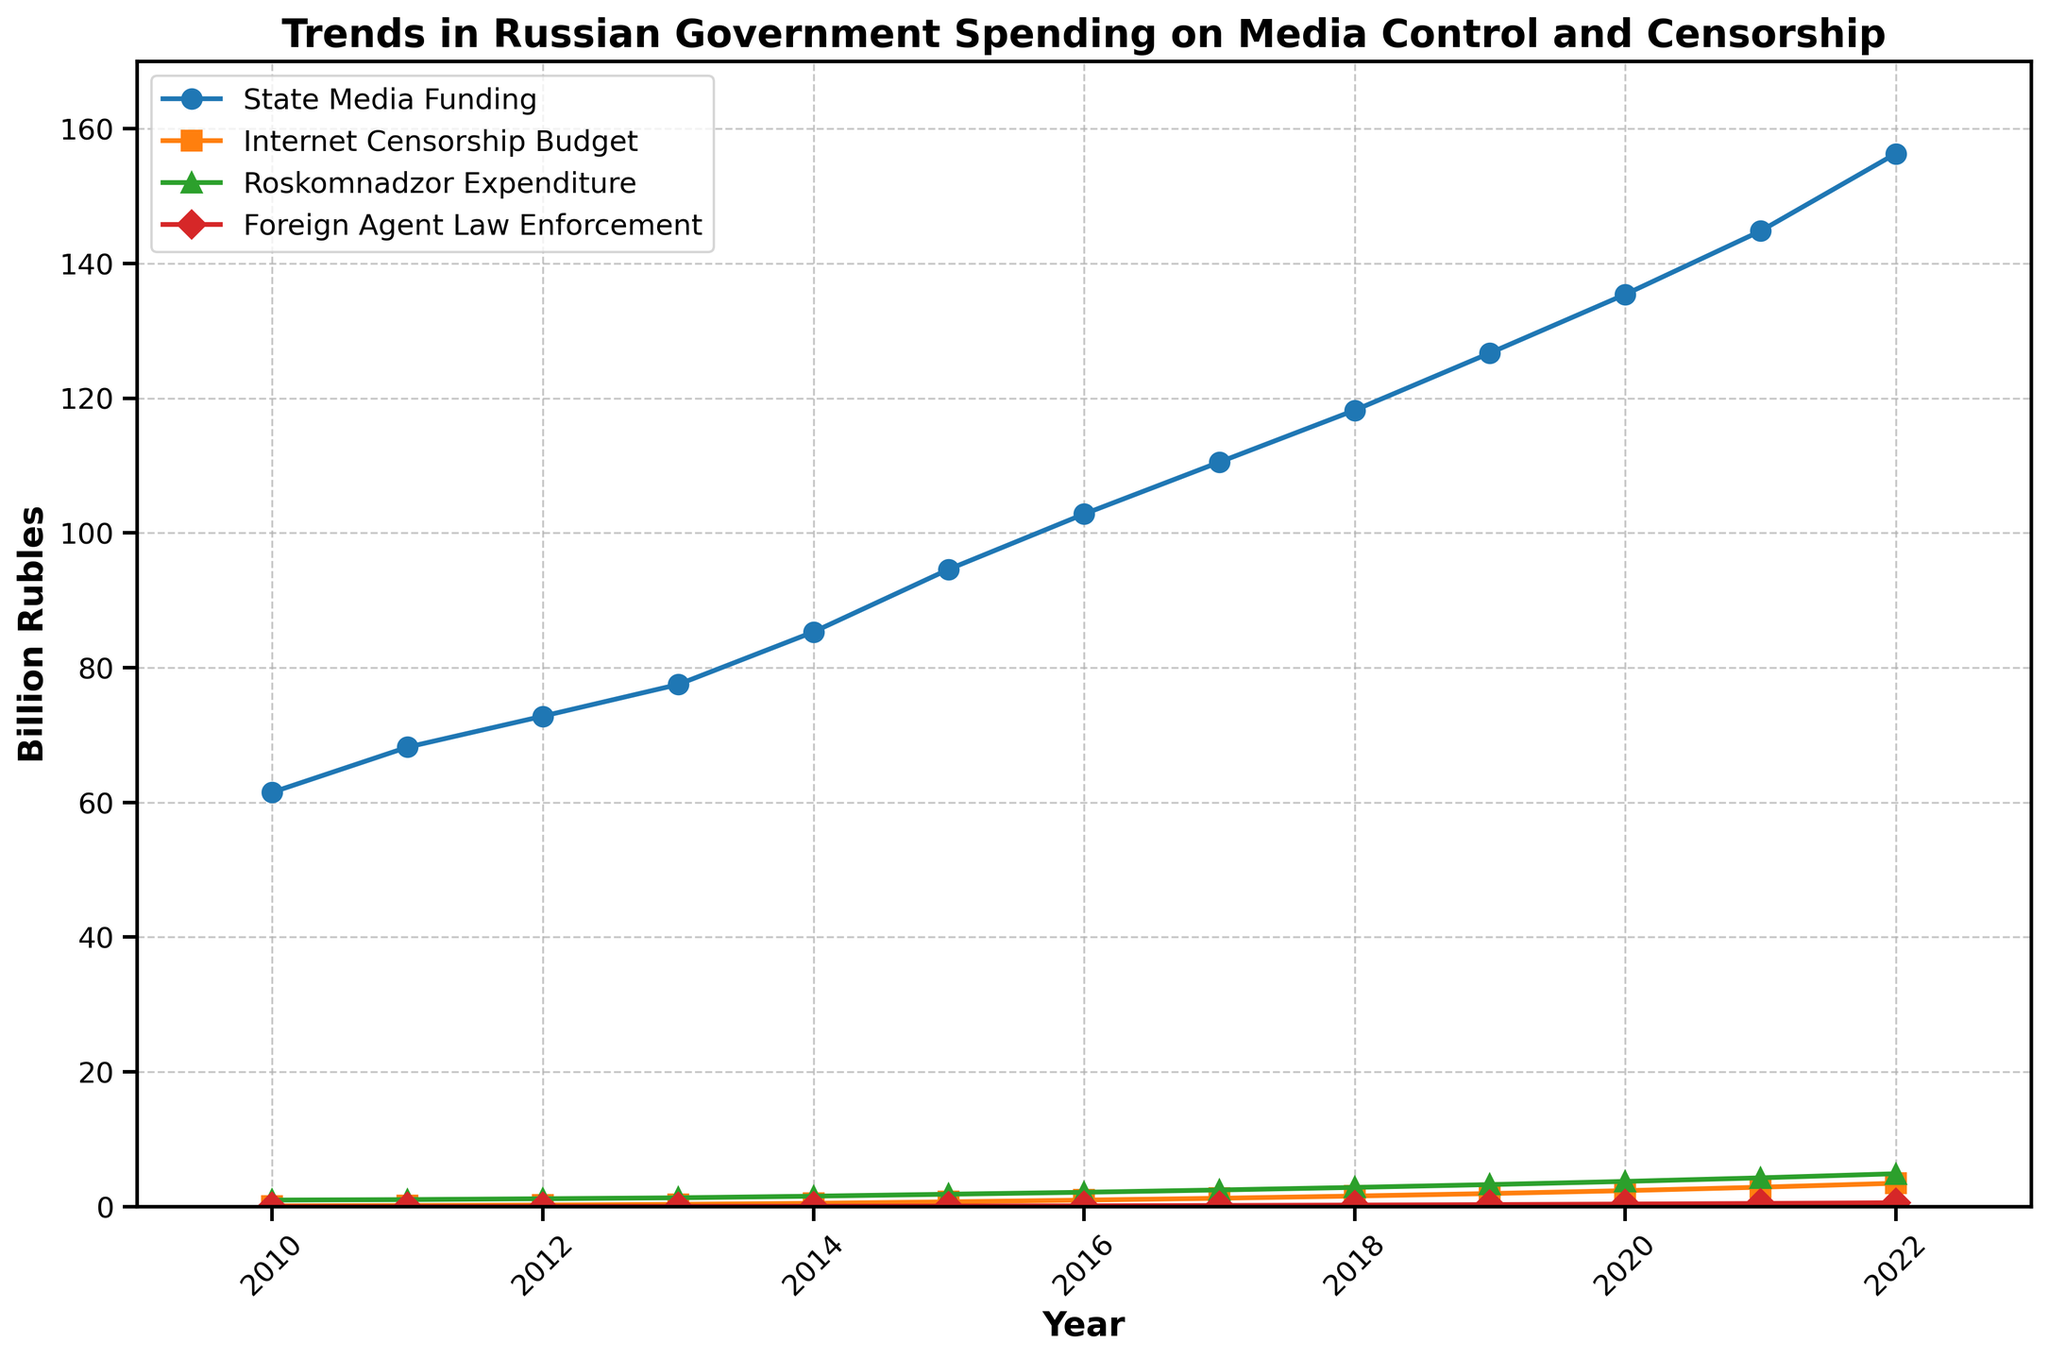How does the budget for Roskomnadzor Expenditure in 2015 compare to the Internet Censorship Budget in the same year? The budget for Roskomnadzor Expenditure in 2015 is 1.85 billion rubles, while the Internet Censorship Budget in the same year is 0.72 billion rubles. Comparing these, Roskomnadzor's budget is greater.
Answer: Roskomnadzor's budget is greater Which year had the highest State Media Funding, and what was its value? The plot shows that the highest State Media Funding occurred in 2022, with a value of 156.3 billion rubles.
Answer: 2022, 156.3 billion rubles Between 2010 and 2022, how many times did the Internet Censorship Budget exceed 1 billion rubles? The Internet Censorship Budget exceeded 1 billion rubles in the years 2016, 2017, 2018, 2019, 2020, 2021, and 2022, which makes it 7 times.
Answer: 7 times What is the approximate difference in the Foreign Agent Law Enforcement budget between 2014 and 2016? In 2014, the Foreign Agent Law Enforcement budget was 0.06 billion rubles, and in 2016 it was 0.13 billion rubles. Therefore, the difference is approximately 0.13 - 0.06 = 0.07 billion rubles.
Answer: 0.07 billion rubles What trends can be observed in the State Media Funding from 2010 to 2022? The State Media Funding shows a consistent upward trend from 61.5 billion rubles in 2010 to 156.3 billion rubles in 2022, indicating an almost steady annual increase.
Answer: Consistent upward trend Among the four categories, which had the smallest budget in 2022, and what was the amount? In 2022, the Foreign Agent Law Enforcement had the smallest budget, amounting to 0.59 billion rubles.
Answer: Foreign Agent Law Enforcement, 0.59 billion rubles How much did the Roskomnadzor Expenditure increase from 2010 to 2022? The Roskomnadzor Expenditure was 0.98 billion rubles in 2010 and increased to 4.89 billion rubles in 2022. The increase is 4.89 - 0.98 = 3.91 billion rubles.
Answer: 3.91 billion rubles What is the average annual increase in State Media Funding between 2010 and 2022? The increase in State Media Funding from 2010 (61.5 billion rubles) to 2022 (156.3 billion rubles) is 156.3 - 61.5 = 94.8 billion rubles over 12 years. The average annual increase is 94.8 / 12 = 7.9 billion rubles per year.
Answer: 7.9 billion rubles per year In 2019, which budgets were more than 3 billion rubles but less than 10 billion rubles? In 2019, the Internet Censorship Budget (1.95 billion rubles) and Roskomnadzor Expenditure (3.28 billion rubles) were considered. Only the Roskomnadzor Expenditure was more than 3 billion rubles and less than 10 billion rubles.
Answer: Roskomnadzor Expenditure 